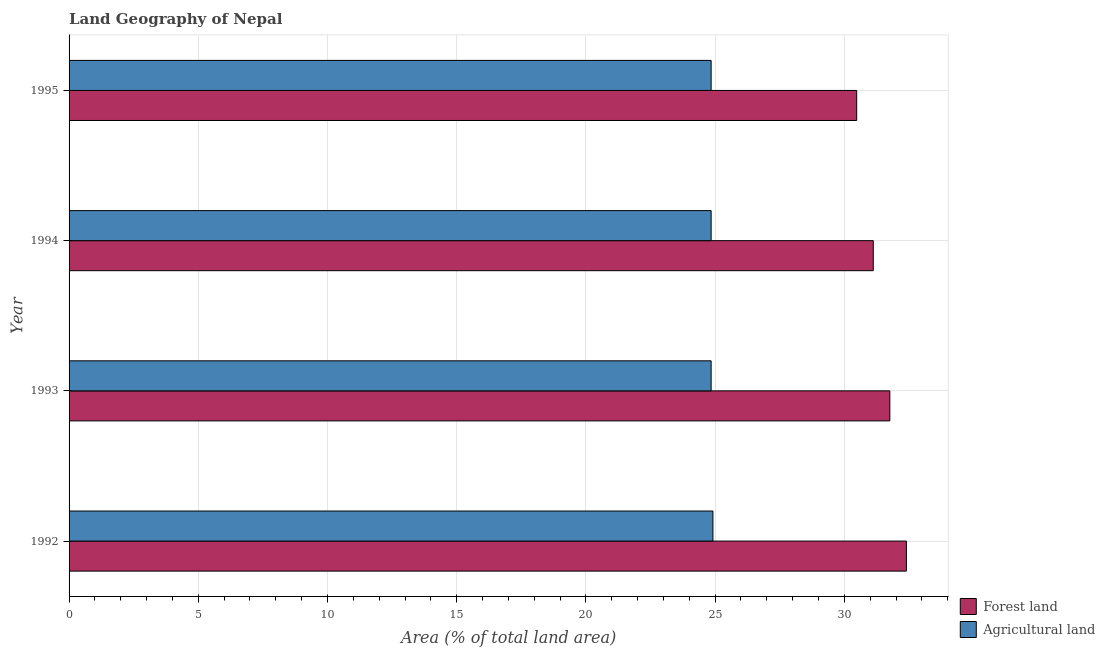How many different coloured bars are there?
Your answer should be very brief. 2. Are the number of bars per tick equal to the number of legend labels?
Provide a short and direct response. Yes. Are the number of bars on each tick of the Y-axis equal?
Give a very brief answer. Yes. How many bars are there on the 4th tick from the bottom?
Ensure brevity in your answer.  2. What is the percentage of land area under agriculture in 1992?
Your answer should be compact. 24.92. Across all years, what is the maximum percentage of land area under forests?
Offer a very short reply. 32.4. Across all years, what is the minimum percentage of land area under forests?
Provide a short and direct response. 30.48. In which year was the percentage of land area under forests maximum?
Provide a short and direct response. 1992. In which year was the percentage of land area under forests minimum?
Offer a terse response. 1995. What is the total percentage of land area under forests in the graph?
Keep it short and to the point. 125.76. What is the difference between the percentage of land area under agriculture in 1994 and the percentage of land area under forests in 1993?
Make the answer very short. -6.92. What is the average percentage of land area under forests per year?
Keep it short and to the point. 31.44. In the year 1992, what is the difference between the percentage of land area under agriculture and percentage of land area under forests?
Offer a very short reply. -7.49. Is the percentage of land area under forests in 1992 less than that in 1995?
Make the answer very short. No. Is the difference between the percentage of land area under forests in 1993 and 1995 greater than the difference between the percentage of land area under agriculture in 1993 and 1995?
Your answer should be very brief. Yes. What is the difference between the highest and the second highest percentage of land area under agriculture?
Give a very brief answer. 0.07. What is the difference between the highest and the lowest percentage of land area under agriculture?
Offer a very short reply. 0.07. In how many years, is the percentage of land area under agriculture greater than the average percentage of land area under agriculture taken over all years?
Give a very brief answer. 1. What does the 2nd bar from the top in 1994 represents?
Keep it short and to the point. Forest land. What does the 1st bar from the bottom in 1993 represents?
Offer a terse response. Forest land. Does the graph contain any zero values?
Your answer should be very brief. No. Where does the legend appear in the graph?
Keep it short and to the point. Bottom right. How are the legend labels stacked?
Give a very brief answer. Vertical. What is the title of the graph?
Provide a short and direct response. Land Geography of Nepal. What is the label or title of the X-axis?
Your answer should be compact. Area (% of total land area). What is the label or title of the Y-axis?
Keep it short and to the point. Year. What is the Area (% of total land area) of Forest land in 1992?
Provide a succinct answer. 32.4. What is the Area (% of total land area) of Agricultural land in 1992?
Your response must be concise. 24.92. What is the Area (% of total land area) in Forest land in 1993?
Keep it short and to the point. 31.76. What is the Area (% of total land area) in Agricultural land in 1993?
Keep it short and to the point. 24.85. What is the Area (% of total land area) in Forest land in 1994?
Your answer should be very brief. 31.12. What is the Area (% of total land area) of Agricultural land in 1994?
Give a very brief answer. 24.85. What is the Area (% of total land area) in Forest land in 1995?
Offer a terse response. 30.48. What is the Area (% of total land area) of Agricultural land in 1995?
Keep it short and to the point. 24.85. Across all years, what is the maximum Area (% of total land area) of Forest land?
Provide a short and direct response. 32.4. Across all years, what is the maximum Area (% of total land area) in Agricultural land?
Keep it short and to the point. 24.92. Across all years, what is the minimum Area (% of total land area) of Forest land?
Offer a terse response. 30.48. Across all years, what is the minimum Area (% of total land area) in Agricultural land?
Provide a short and direct response. 24.85. What is the total Area (% of total land area) of Forest land in the graph?
Your answer should be compact. 125.76. What is the total Area (% of total land area) of Agricultural land in the graph?
Provide a short and direct response. 99.45. What is the difference between the Area (% of total land area) of Forest land in 1992 and that in 1993?
Ensure brevity in your answer.  0.64. What is the difference between the Area (% of total land area) in Agricultural land in 1992 and that in 1993?
Offer a terse response. 0.07. What is the difference between the Area (% of total land area) in Forest land in 1992 and that in 1994?
Provide a succinct answer. 1.28. What is the difference between the Area (% of total land area) in Agricultural land in 1992 and that in 1994?
Make the answer very short. 0.07. What is the difference between the Area (% of total land area) of Forest land in 1992 and that in 1995?
Your answer should be very brief. 1.92. What is the difference between the Area (% of total land area) of Agricultural land in 1992 and that in 1995?
Offer a very short reply. 0.07. What is the difference between the Area (% of total land area) in Forest land in 1993 and that in 1994?
Make the answer very short. 0.64. What is the difference between the Area (% of total land area) in Agricultural land in 1993 and that in 1994?
Your answer should be compact. 0. What is the difference between the Area (% of total land area) in Forest land in 1993 and that in 1995?
Keep it short and to the point. 1.28. What is the difference between the Area (% of total land area) of Agricultural land in 1993 and that in 1995?
Provide a succinct answer. 0. What is the difference between the Area (% of total land area) in Forest land in 1994 and that in 1995?
Keep it short and to the point. 0.64. What is the difference between the Area (% of total land area) of Forest land in 1992 and the Area (% of total land area) of Agricultural land in 1993?
Make the answer very short. 7.56. What is the difference between the Area (% of total land area) in Forest land in 1992 and the Area (% of total land area) in Agricultural land in 1994?
Your answer should be very brief. 7.56. What is the difference between the Area (% of total land area) in Forest land in 1992 and the Area (% of total land area) in Agricultural land in 1995?
Provide a succinct answer. 7.56. What is the difference between the Area (% of total land area) in Forest land in 1993 and the Area (% of total land area) in Agricultural land in 1994?
Your answer should be very brief. 6.92. What is the difference between the Area (% of total land area) in Forest land in 1993 and the Area (% of total land area) in Agricultural land in 1995?
Your response must be concise. 6.92. What is the difference between the Area (% of total land area) of Forest land in 1994 and the Area (% of total land area) of Agricultural land in 1995?
Your answer should be compact. 6.27. What is the average Area (% of total land area) of Forest land per year?
Give a very brief answer. 31.44. What is the average Area (% of total land area) in Agricultural land per year?
Keep it short and to the point. 24.86. In the year 1992, what is the difference between the Area (% of total land area) in Forest land and Area (% of total land area) in Agricultural land?
Give a very brief answer. 7.49. In the year 1993, what is the difference between the Area (% of total land area) in Forest land and Area (% of total land area) in Agricultural land?
Make the answer very short. 6.92. In the year 1994, what is the difference between the Area (% of total land area) in Forest land and Area (% of total land area) in Agricultural land?
Offer a very short reply. 6.27. In the year 1995, what is the difference between the Area (% of total land area) in Forest land and Area (% of total land area) in Agricultural land?
Your response must be concise. 5.63. What is the ratio of the Area (% of total land area) of Forest land in 1992 to that in 1993?
Provide a short and direct response. 1.02. What is the ratio of the Area (% of total land area) in Forest land in 1992 to that in 1994?
Offer a very short reply. 1.04. What is the ratio of the Area (% of total land area) in Agricultural land in 1992 to that in 1994?
Keep it short and to the point. 1. What is the ratio of the Area (% of total land area) of Forest land in 1992 to that in 1995?
Provide a short and direct response. 1.06. What is the ratio of the Area (% of total land area) in Agricultural land in 1992 to that in 1995?
Ensure brevity in your answer.  1. What is the ratio of the Area (% of total land area) of Forest land in 1993 to that in 1994?
Give a very brief answer. 1.02. What is the ratio of the Area (% of total land area) of Agricultural land in 1993 to that in 1994?
Keep it short and to the point. 1. What is the ratio of the Area (% of total land area) in Forest land in 1993 to that in 1995?
Offer a very short reply. 1.04. What is the ratio of the Area (% of total land area) of Forest land in 1994 to that in 1995?
Make the answer very short. 1.02. What is the difference between the highest and the second highest Area (% of total land area) of Forest land?
Give a very brief answer. 0.64. What is the difference between the highest and the second highest Area (% of total land area) in Agricultural land?
Your answer should be very brief. 0.07. What is the difference between the highest and the lowest Area (% of total land area) of Forest land?
Your answer should be very brief. 1.92. What is the difference between the highest and the lowest Area (% of total land area) of Agricultural land?
Offer a very short reply. 0.07. 